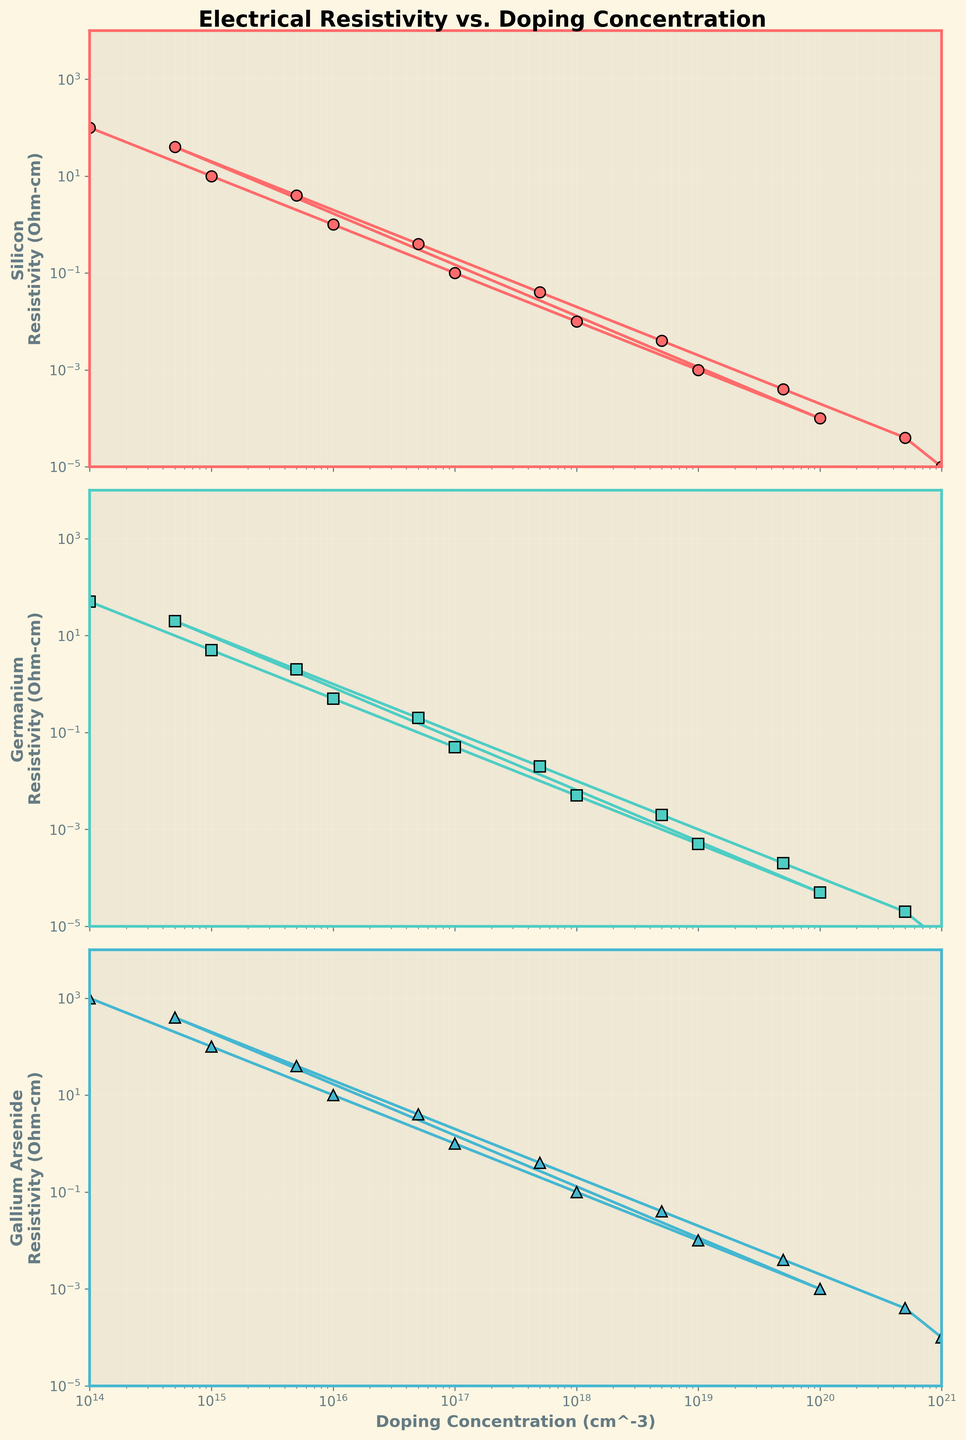What is the relationship between doping concentration and resistivity for Silicon? As doping concentration increases, the resistivity of Silicon decreases. This inverse relationship can be seen as the line on the plot slopes downward from left to right.
Answer: Inverse relationship At which doping concentration does Germanium show a resistivity of 0.5 Ohm-cm? By looking at the Germanium resistivity plot, 0.5 Ohm-cm is reached at a doping concentration close to 1e16 cm^-3.
Answer: ~1e16 cm^-3 Between Silicon, Germanium, and Gallium Arsenide, which material has the highest resistivity at a doping concentration of 1e17 cm^-3? At 1e17 cm^-3, Gallium Arsenide has the highest resistivity (~1 Ohm-cm) compared to Silicon (~0.1 Ohm-cm) and Germanium (~0.05 Ohm-cm).
Answer: Gallium Arsenide How does the resistivity of Gallium Arsenide change when the doping concentration increases from 1e18 cm^-3 to 5e18 cm^-3? The resistivity of Gallium Arsenide decreases from ~0.1 Ohm-cm to ~0.04 Ohm-cm as the doping concentration increases from 1e18 cm^-3 to 5e18 cm^-3.
Answer: Decreases Compare the rate of change in resistivity between Silicon and Germanium when doping concentration changes from 1e19 cm^-3 to 5e19 cm^-3. For Silicon, the resistivity drops from ~0.001 Ohm-cm to ~0.0004 Ohm-cm, a change of ~0.0006 Ohm-cm. For Germanium, it changes from ~0.0005 Ohm-cm to ~0.0002 Ohm-cm, a change of ~0.0003 Ohm-cm. So, Silicon shows a larger rate of change.
Answer: Silicon has a larger rate of change If the doping concentration is at 1e20 cm^-3, what is the approximate resistivity difference between Silicon and Gallium Arsenide? At 1e20 cm^-3, the resistivity for Silicon is ~0.0001 Ohm-cm, and for Gallium Arsenide, it is ~0.001 Ohm-cm. The difference is ~0.001 - 0.0001 = 0.0009 Ohm-cm.
Answer: ~0.0009 Ohm-cm What is the general trend of resistivity for all three materials as doping concentration increases? For all three materials (Silicon, Germanium, Gallium Arsenide), the resistivity consistently decreases as the doping concentration increases. This trend is observed across all subplot lines sloping downward.
Answer: Decreasing trend At which doping concentration do all three materials have their resistivity values within the same order of magnitude for the first time? At doping concentration 1e17 cm^-3, all resistivity values for Silicon (~0.1 Ohm-cm), Germanium (~0.05 Ohm-cm), and Gallium Arsenide (~1 Ohm-cm) are within the same order of magnitude (10^-1).
Answer: 1e17 cm^-3 